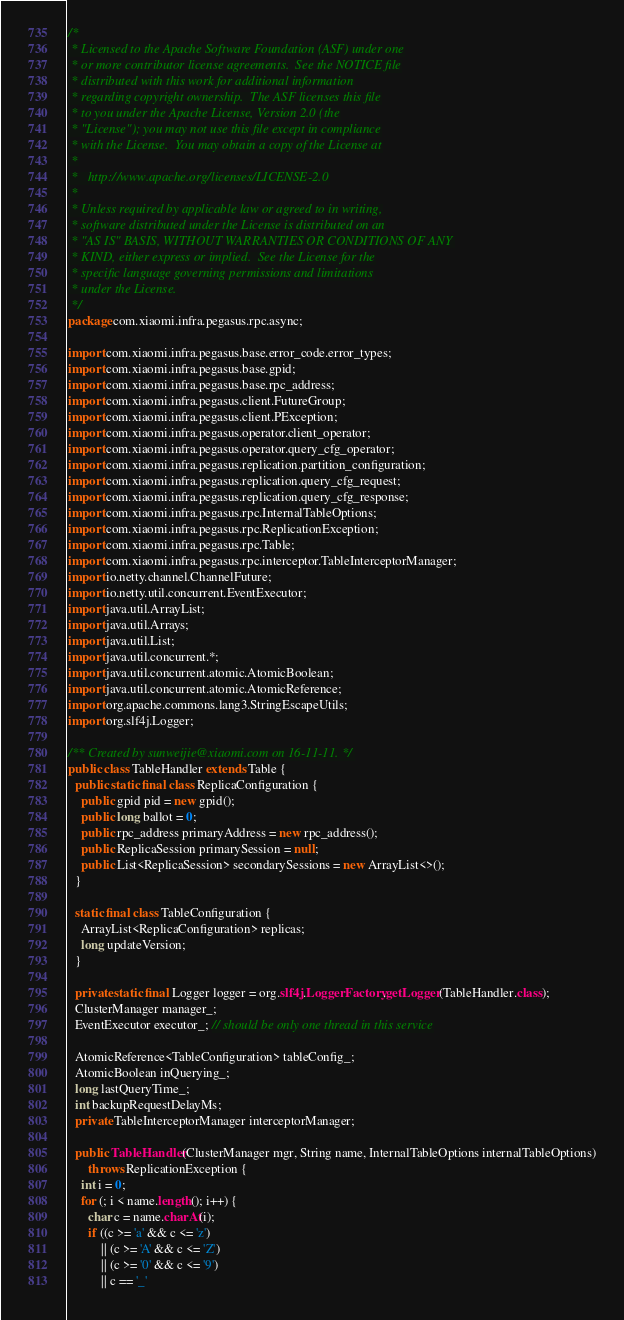Convert code to text. <code><loc_0><loc_0><loc_500><loc_500><_Java_>/*
 * Licensed to the Apache Software Foundation (ASF) under one
 * or more contributor license agreements.  See the NOTICE file
 * distributed with this work for additional information
 * regarding copyright ownership.  The ASF licenses this file
 * to you under the Apache License, Version 2.0 (the
 * "License"); you may not use this file except in compliance
 * with the License.  You may obtain a copy of the License at
 *
 *   http://www.apache.org/licenses/LICENSE-2.0
 *
 * Unless required by applicable law or agreed to in writing,
 * software distributed under the License is distributed on an
 * "AS IS" BASIS, WITHOUT WARRANTIES OR CONDITIONS OF ANY
 * KIND, either express or implied.  See the License for the
 * specific language governing permissions and limitations
 * under the License.
 */
package com.xiaomi.infra.pegasus.rpc.async;

import com.xiaomi.infra.pegasus.base.error_code.error_types;
import com.xiaomi.infra.pegasus.base.gpid;
import com.xiaomi.infra.pegasus.base.rpc_address;
import com.xiaomi.infra.pegasus.client.FutureGroup;
import com.xiaomi.infra.pegasus.client.PException;
import com.xiaomi.infra.pegasus.operator.client_operator;
import com.xiaomi.infra.pegasus.operator.query_cfg_operator;
import com.xiaomi.infra.pegasus.replication.partition_configuration;
import com.xiaomi.infra.pegasus.replication.query_cfg_request;
import com.xiaomi.infra.pegasus.replication.query_cfg_response;
import com.xiaomi.infra.pegasus.rpc.InternalTableOptions;
import com.xiaomi.infra.pegasus.rpc.ReplicationException;
import com.xiaomi.infra.pegasus.rpc.Table;
import com.xiaomi.infra.pegasus.rpc.interceptor.TableInterceptorManager;
import io.netty.channel.ChannelFuture;
import io.netty.util.concurrent.EventExecutor;
import java.util.ArrayList;
import java.util.Arrays;
import java.util.List;
import java.util.concurrent.*;
import java.util.concurrent.atomic.AtomicBoolean;
import java.util.concurrent.atomic.AtomicReference;
import org.apache.commons.lang3.StringEscapeUtils;
import org.slf4j.Logger;

/** Created by sunweijie@xiaomi.com on 16-11-11. */
public class TableHandler extends Table {
  public static final class ReplicaConfiguration {
    public gpid pid = new gpid();
    public long ballot = 0;
    public rpc_address primaryAddress = new rpc_address();
    public ReplicaSession primarySession = null;
    public List<ReplicaSession> secondarySessions = new ArrayList<>();
  }

  static final class TableConfiguration {
    ArrayList<ReplicaConfiguration> replicas;
    long updateVersion;
  }

  private static final Logger logger = org.slf4j.LoggerFactory.getLogger(TableHandler.class);
  ClusterManager manager_;
  EventExecutor executor_; // should be only one thread in this service

  AtomicReference<TableConfiguration> tableConfig_;
  AtomicBoolean inQuerying_;
  long lastQueryTime_;
  int backupRequestDelayMs;
  private TableInterceptorManager interceptorManager;

  public TableHandler(ClusterManager mgr, String name, InternalTableOptions internalTableOptions)
      throws ReplicationException {
    int i = 0;
    for (; i < name.length(); i++) {
      char c = name.charAt(i);
      if ((c >= 'a' && c <= 'z')
          || (c >= 'A' && c <= 'Z')
          || (c >= '0' && c <= '9')
          || c == '_'</code> 